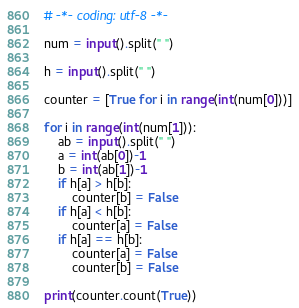Convert code to text. <code><loc_0><loc_0><loc_500><loc_500><_Python_># -*- coding: utf-8 -*-

num = input().split(" ")

h = input().split(" ")

counter = [True for i in range(int(num[0]))]

for i in range(int(num[1])):
    ab = input().split(" ")
    a = int(ab[0])-1
    b = int(ab[1])-1
    if h[a] > h[b]:
        counter[b] = False
    if h[a] < h[b]:
        counter[a] = False
    if h[a] == h[b]:
        counter[a] = False
        counter[b] = False
        
print(counter.count(True))</code> 